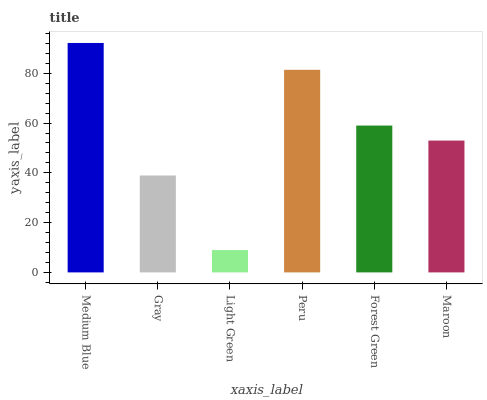Is Light Green the minimum?
Answer yes or no. Yes. Is Medium Blue the maximum?
Answer yes or no. Yes. Is Gray the minimum?
Answer yes or no. No. Is Gray the maximum?
Answer yes or no. No. Is Medium Blue greater than Gray?
Answer yes or no. Yes. Is Gray less than Medium Blue?
Answer yes or no. Yes. Is Gray greater than Medium Blue?
Answer yes or no. No. Is Medium Blue less than Gray?
Answer yes or no. No. Is Forest Green the high median?
Answer yes or no. Yes. Is Maroon the low median?
Answer yes or no. Yes. Is Maroon the high median?
Answer yes or no. No. Is Forest Green the low median?
Answer yes or no. No. 